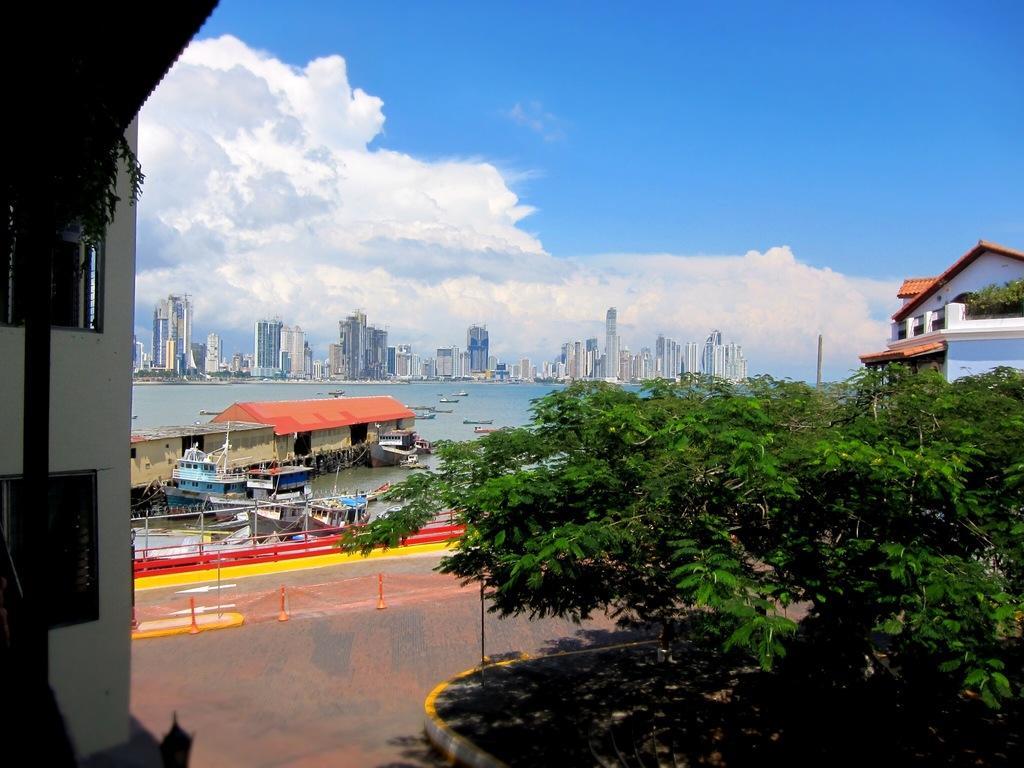Could you give a brief overview of what you see in this image? In the center of the image there is a lake and we can see boats on the lake. At the bottom there are trees. In the background there are buildings and sky. 